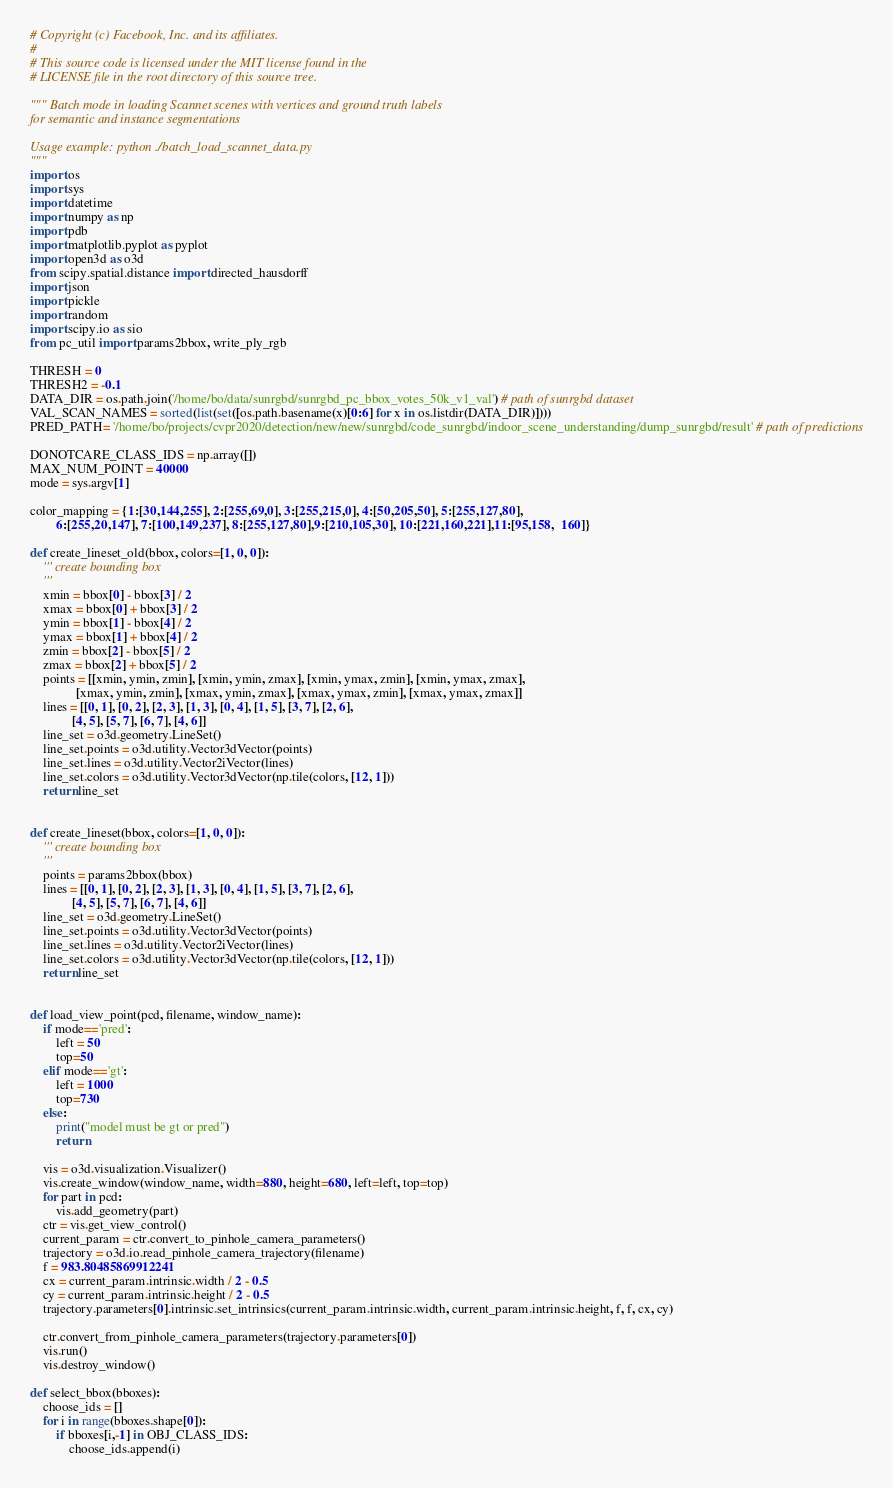Convert code to text. <code><loc_0><loc_0><loc_500><loc_500><_Python_># Copyright (c) Facebook, Inc. and its affiliates.
#
# This source code is licensed under the MIT license found in the
# LICENSE file in the root directory of this source tree.

""" Batch mode in loading Scannet scenes with vertices and ground truth labels
for semantic and instance segmentations

Usage example: python ./batch_load_scannet_data.py
"""
import os
import sys
import datetime
import numpy as np
import pdb
import matplotlib.pyplot as pyplot
import open3d as o3d
from scipy.spatial.distance import directed_hausdorff
import json
import pickle
import random
import scipy.io as sio
from pc_util import params2bbox, write_ply_rgb

THRESH = 0
THRESH2 = -0.1
DATA_DIR = os.path.join('/home/bo/data/sunrgbd/sunrgbd_pc_bbox_votes_50k_v1_val') # path of sunrgbd dataset 
VAL_SCAN_NAMES = sorted(list(set([os.path.basename(x)[0:6] for x in os.listdir(DATA_DIR)])))
PRED_PATH= '/home/bo/projects/cvpr2020/detection/new/new/sunrgbd/code_sunrgbd/indoor_scene_understanding/dump_sunrgbd/result' # path of predictions

DONOTCARE_CLASS_IDS = np.array([])
MAX_NUM_POINT = 40000
mode = sys.argv[1]

color_mapping = {1:[30,144,255], 2:[255,69,0], 3:[255,215,0], 4:[50,205,50], 5:[255,127,80],
        6:[255,20,147], 7:[100,149,237], 8:[255,127,80],9:[210,105,30], 10:[221,160,221],11:[95,158,  160]}

def create_lineset_old(bbox, colors=[1, 0, 0]):
    ''' create bounding box
    '''
    xmin = bbox[0] - bbox[3] / 2
    xmax = bbox[0] + bbox[3] / 2
    ymin = bbox[1] - bbox[4] / 2
    ymax = bbox[1] + bbox[4] / 2
    zmin = bbox[2] - bbox[5] / 2
    zmax = bbox[2] + bbox[5] / 2
    points = [[xmin, ymin, zmin], [xmin, ymin, zmax], [xmin, ymax, zmin], [xmin, ymax, zmax],
              [xmax, ymin, zmin], [xmax, ymin, zmax], [xmax, ymax, zmin], [xmax, ymax, zmax]]
    lines = [[0, 1], [0, 2], [2, 3], [1, 3], [0, 4], [1, 5], [3, 7], [2, 6],
             [4, 5], [5, 7], [6, 7], [4, 6]]
    line_set = o3d.geometry.LineSet()
    line_set.points = o3d.utility.Vector3dVector(points)
    line_set.lines = o3d.utility.Vector2iVector(lines)
    line_set.colors = o3d.utility.Vector3dVector(np.tile(colors, [12, 1]))
    return line_set


def create_lineset(bbox, colors=[1, 0, 0]):
    ''' create bounding box
    '''
    points = params2bbox(bbox)
    lines = [[0, 1], [0, 2], [2, 3], [1, 3], [0, 4], [1, 5], [3, 7], [2, 6],
             [4, 5], [5, 7], [6, 7], [4, 6]]
    line_set = o3d.geometry.LineSet()
    line_set.points = o3d.utility.Vector3dVector(points)
    line_set.lines = o3d.utility.Vector2iVector(lines)
    line_set.colors = o3d.utility.Vector3dVector(np.tile(colors, [12, 1]))
    return line_set


def load_view_point(pcd, filename, window_name):
    if mode=='pred':
        left = 50
        top=50
    elif mode=='gt':
        left = 1000
        top=730
    else:
        print("model must be gt or pred")
        return

    vis = o3d.visualization.Visualizer()
    vis.create_window(window_name, width=880, height=680, left=left, top=top)
    for part in pcd:
        vis.add_geometry(part)
    ctr = vis.get_view_control()
    current_param = ctr.convert_to_pinhole_camera_parameters()
    trajectory = o3d.io.read_pinhole_camera_trajectory(filename)
    f = 983.80485869912241
    cx = current_param.intrinsic.width / 2 - 0.5
    cy = current_param.intrinsic.height / 2 - 0.5
    trajectory.parameters[0].intrinsic.set_intrinsics(current_param.intrinsic.width, current_param.intrinsic.height, f, f, cx, cy)

    ctr.convert_from_pinhole_camera_parameters(trajectory.parameters[0])
    vis.run()
    vis.destroy_window()

def select_bbox(bboxes):
    choose_ids = []
    for i in range(bboxes.shape[0]):
        if bboxes[i,-1] in OBJ_CLASS_IDS:
            choose_ids.append(i)</code> 